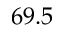Convert formula to latex. <formula><loc_0><loc_0><loc_500><loc_500>6 9 . 5</formula> 